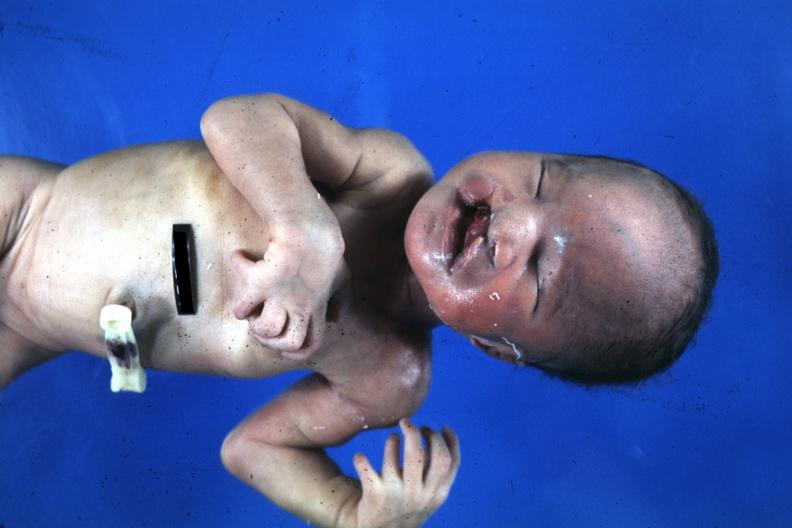s abruption present?
Answer the question using a single word or phrase. No 